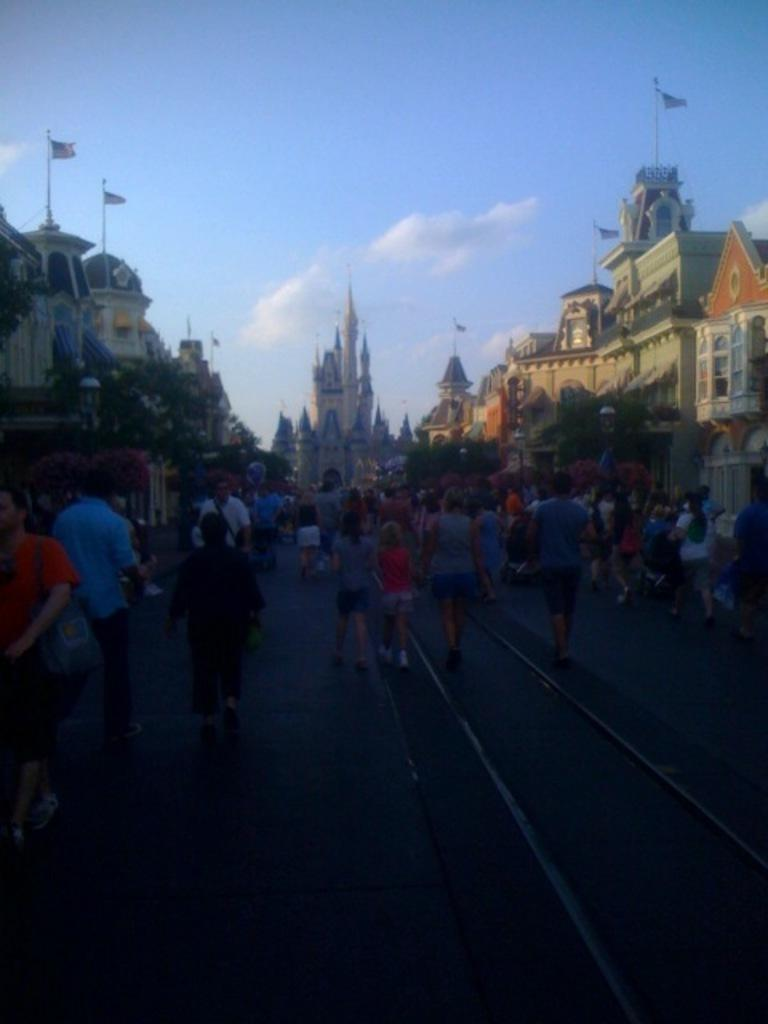How many people are in the image? There is a group of persons in the image. What can be seen in the background of the image? There are buildings visible in the background of the image. What is visible at the top of the image? The sky is visible at the top of the image. Can you tell me how many monkeys are sitting on the shoulders of the persons in the image? There are no monkeys present in the image. What type of insect can be seen flying around the group of persons in the image? There are no insects visible in the image. 